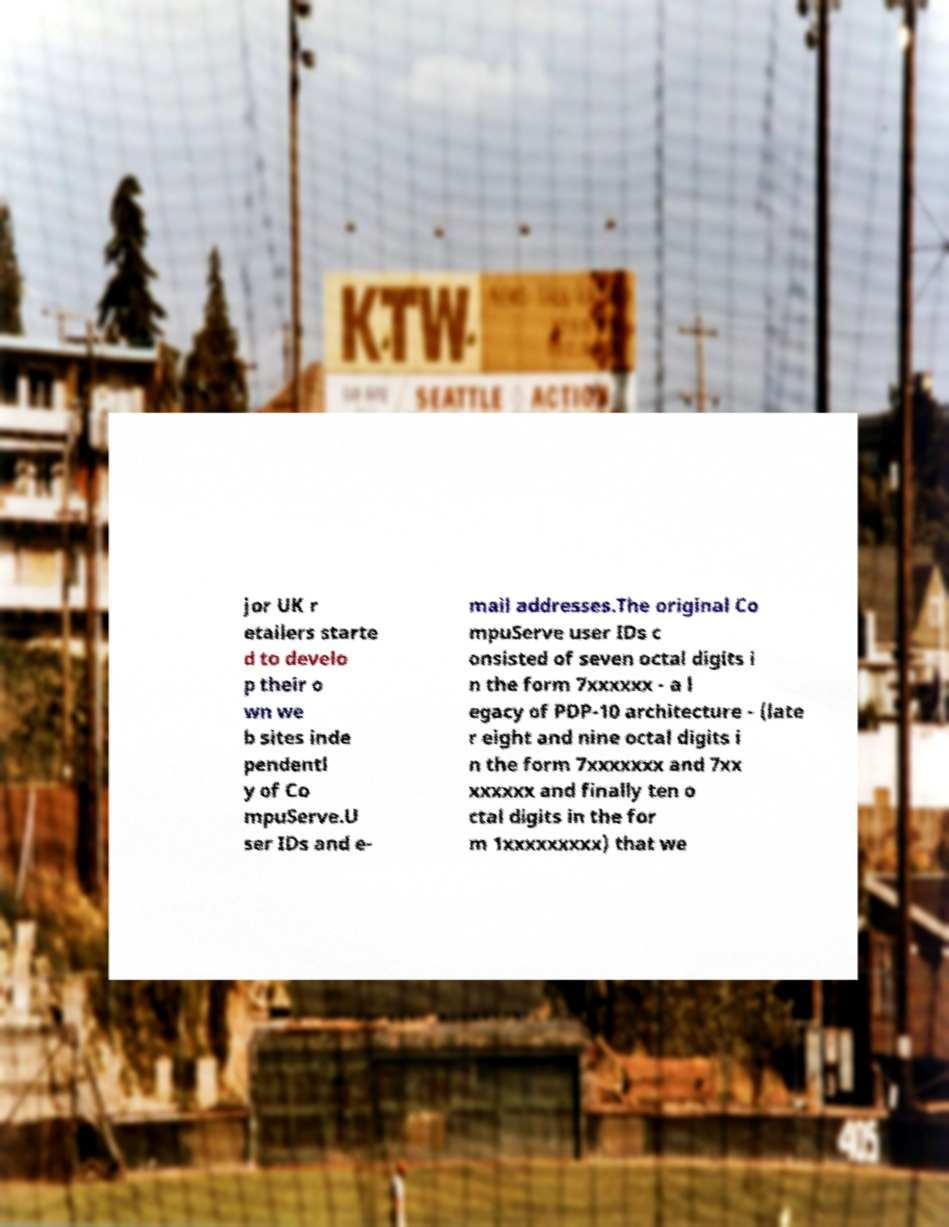Could you assist in decoding the text presented in this image and type it out clearly? jor UK r etailers starte d to develo p their o wn we b sites inde pendentl y of Co mpuServe.U ser IDs and e- mail addresses.The original Co mpuServe user IDs c onsisted of seven octal digits i n the form 7xxxxxx - a l egacy of PDP-10 architecture - (late r eight and nine octal digits i n the form 7xxxxxxx and 7xx xxxxxx and finally ten o ctal digits in the for m 1xxxxxxxxx) that we 